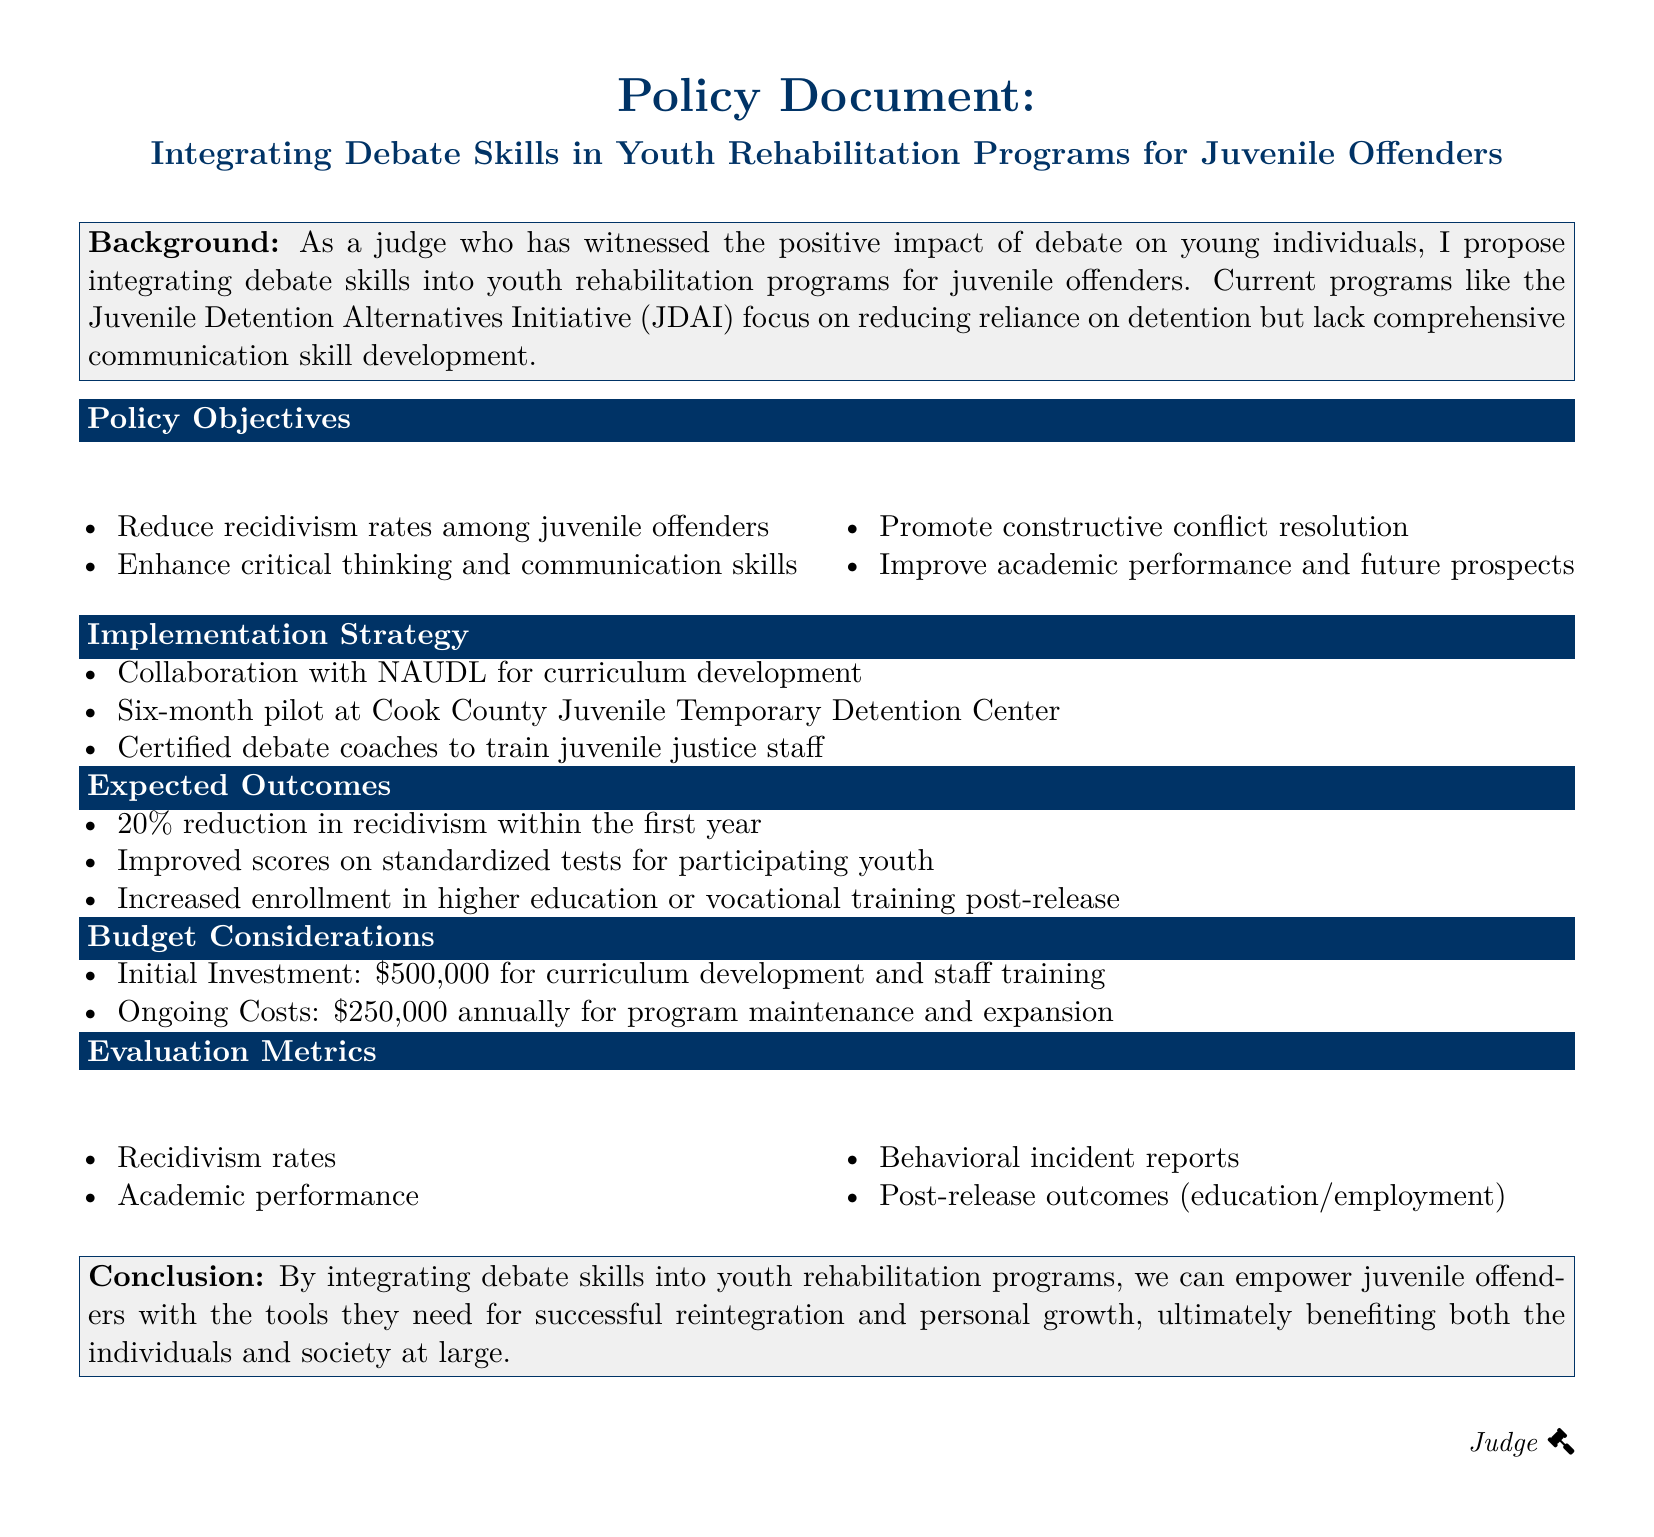What is the initial investment for the program? The initial investment for curriculum development and staff training is outlined in the budget considerations.
Answer: $500,000 What percentage reduction in recidivism is expected within the first year? The expected outcomes include a projected reduction in recidivism, specified as a percentage.
Answer: 20% Which organization is collaborating for curriculum development? The implementation strategy mentions a specific organization working with the program.
Answer: NAUDL What type of skills are being targeted for enhancement in the juvenile offenders? The policy objectives list a key focus for skill enhancement.
Answer: Communication skills What is the annual ongoing cost for program maintenance? This cost is detailed under the budget considerations section.
Answer: $250,000 What is the expected improvement in academic outcomes after participation? The expected outcomes include a reference to the academic performance of participating youth.
Answer: Scores on standardized tests What is the duration of the pilot program at Cook County? The implementation strategy specifies the length of the pilot program.
Answer: Six months What are the behavioral metrics used for evaluation? The evaluation metrics include specific aspects to be tracked after the implementation of the program.
Answer: Behavioral incident reports What is the main goal of integrating debate skills into rehabilitation programs? The conclusion summarizes the overarching aim of this integration.
Answer: Empower juvenile offenders 